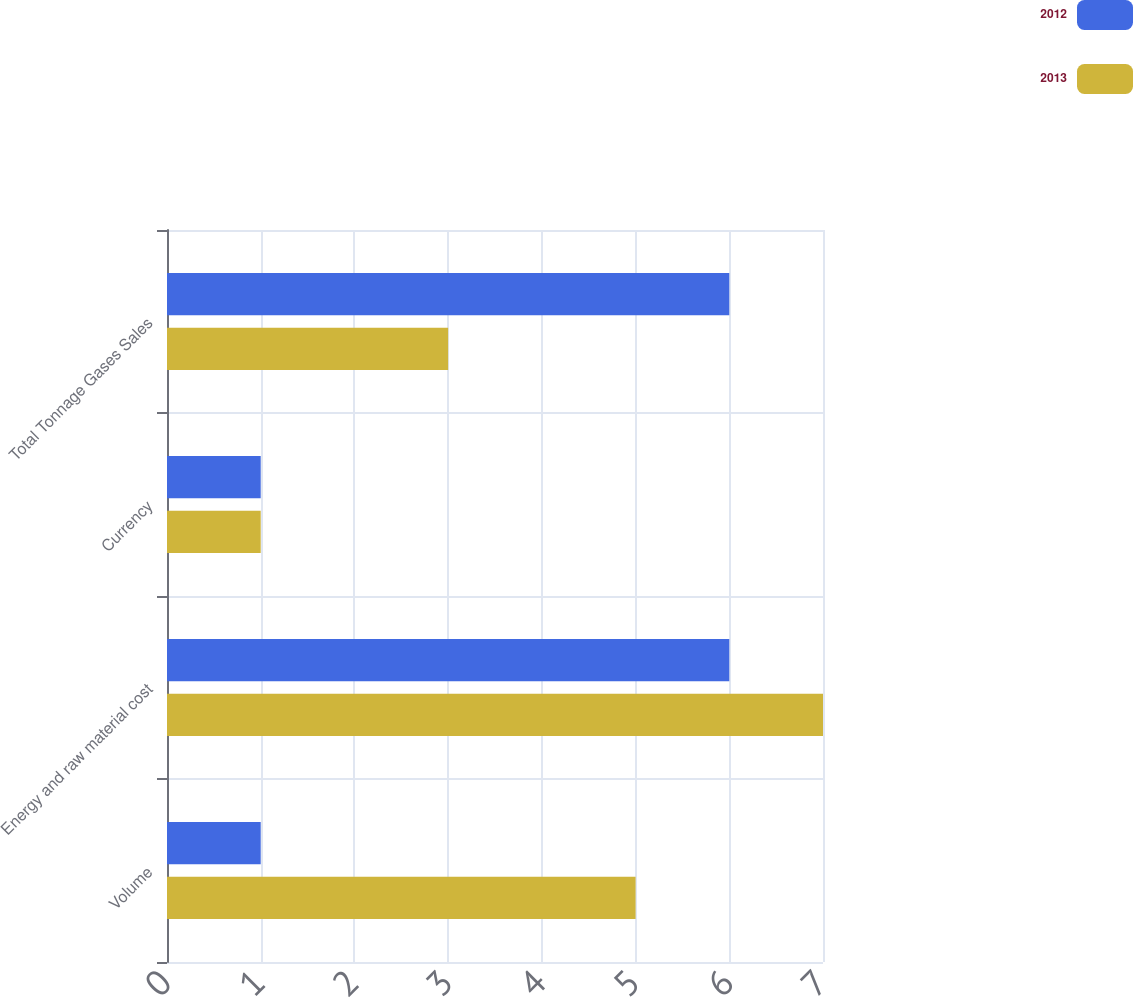<chart> <loc_0><loc_0><loc_500><loc_500><stacked_bar_chart><ecel><fcel>Volume<fcel>Energy and raw material cost<fcel>Currency<fcel>Total Tonnage Gases Sales<nl><fcel>2012<fcel>1<fcel>6<fcel>1<fcel>6<nl><fcel>2013<fcel>5<fcel>7<fcel>1<fcel>3<nl></chart> 